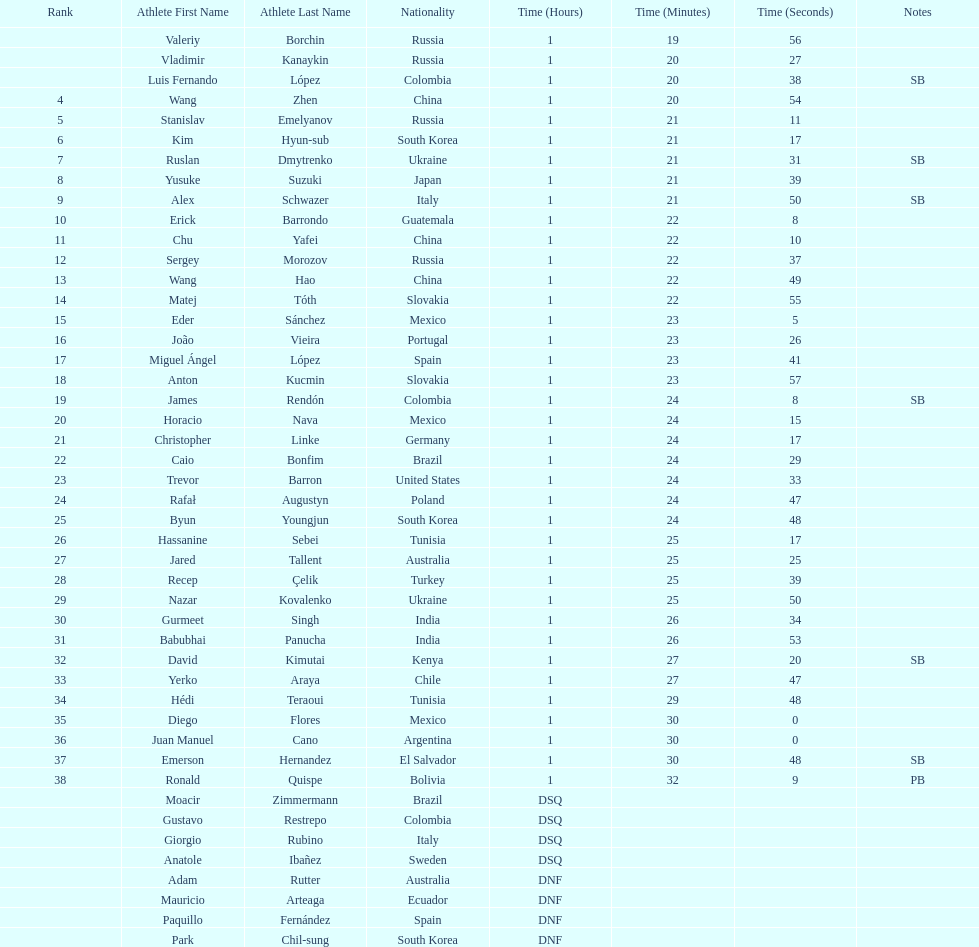Which athlete is the only american to be ranked in the 20km? Trevor Barron. Would you be able to parse every entry in this table? {'header': ['Rank', 'Athlete First Name', 'Athlete Last Name', 'Nationality', 'Time (Hours)', 'Time (Minutes)', 'Time (Seconds)', 'Notes'], 'rows': [['', 'Valeriy', 'Borchin', 'Russia', '1', '19', '56', ''], ['', 'Vladimir', 'Kanaykin', 'Russia', '1', '20', '27', ''], ['', 'Luis Fernando', 'López', 'Colombia', '1', '20', '38', 'SB'], ['4', 'Wang', 'Zhen', 'China', '1', '20', '54', ''], ['5', 'Stanislav', 'Emelyanov', 'Russia', '1', '21', '11', ''], ['6', 'Kim', 'Hyun-sub', 'South Korea', '1', '21', '17', ''], ['7', 'Ruslan', 'Dmytrenko', 'Ukraine', '1', '21', '31', 'SB'], ['8', 'Yusuke', 'Suzuki', 'Japan', '1', '21', '39', ''], ['9', 'Alex', 'Schwazer', 'Italy', '1', '21', '50', 'SB'], ['10', 'Erick', 'Barrondo', 'Guatemala', '1', '22', '8', ''], ['11', 'Chu', 'Yafei', 'China', '1', '22', '10', ''], ['12', 'Sergey', 'Morozov', 'Russia', '1', '22', '37', ''], ['13', 'Wang', 'Hao', 'China', '1', '22', '49', ''], ['14', 'Matej', 'Tóth', 'Slovakia', '1', '22', '55', ''], ['15', 'Eder', 'Sánchez', 'Mexico', '1', '23', '5', ''], ['16', 'João', 'Vieira', 'Portugal', '1', '23', '26', ''], ['17', 'Miguel Ángel', 'López', 'Spain', '1', '23', '41', ''], ['18', 'Anton', 'Kucmin', 'Slovakia', '1', '23', '57', ''], ['19', 'James', 'Rendón', 'Colombia', '1', '24', '8', 'SB'], ['20', 'Horacio', 'Nava', 'Mexico', '1', '24', '15', ''], ['21', 'Christopher', 'Linke', 'Germany', '1', '24', '17', ''], ['22', 'Caio', 'Bonfim', 'Brazil', '1', '24', '29', ''], ['23', 'Trevor', 'Barron', 'United States', '1', '24', '33', ''], ['24', 'Rafał', 'Augustyn', 'Poland', '1', '24', '47', ''], ['25', 'Byun', 'Youngjun', 'South Korea', '1', '24', '48', ''], ['26', 'Hassanine', 'Sebei', 'Tunisia', '1', '25', '17', ''], ['27', 'Jared', 'Tallent', 'Australia', '1', '25', '25', ''], ['28', 'Recep', 'Çelik', 'Turkey', '1', '25', '39', ''], ['29', 'Nazar', 'Kovalenko', 'Ukraine', '1', '25', '50', ''], ['30', 'Gurmeet', 'Singh', 'India', '1', '26', '34', ''], ['31', 'Babubhai', 'Panucha', 'India', '1', '26', '53', ''], ['32', 'David', 'Kimutai', 'Kenya', '1', '27', '20', 'SB'], ['33', 'Yerko', 'Araya', 'Chile', '1', '27', '47', ''], ['34', 'Hédi', 'Teraoui', 'Tunisia', '1', '29', '48', ''], ['35', 'Diego', 'Flores', 'Mexico', '1', '30', '0', ''], ['36', 'Juan Manuel', 'Cano', 'Argentina', '1', '30', '0', ''], ['37', 'Emerson', 'Hernandez', 'El Salvador', '1', '30', '48', 'SB'], ['38', 'Ronald', 'Quispe', 'Bolivia', '1', '32', '9', 'PB'], ['', 'Moacir', 'Zimmermann', 'Brazil', 'DSQ', '', '', ''], ['', 'Gustavo', 'Restrepo', 'Colombia', 'DSQ', '', '', ''], ['', 'Giorgio', 'Rubino', 'Italy', 'DSQ', '', '', ''], ['', 'Anatole', 'Ibañez', 'Sweden', 'DSQ', '', '', ''], ['', 'Adam', 'Rutter', 'Australia', 'DNF', '', '', ''], ['', 'Mauricio', 'Arteaga', 'Ecuador', 'DNF', '', '', ''], ['', 'Paquillo', 'Fernández', 'Spain', 'DNF', '', '', ''], ['', 'Park', 'Chil-sung', 'South Korea', 'DNF', '', '', '']]} 